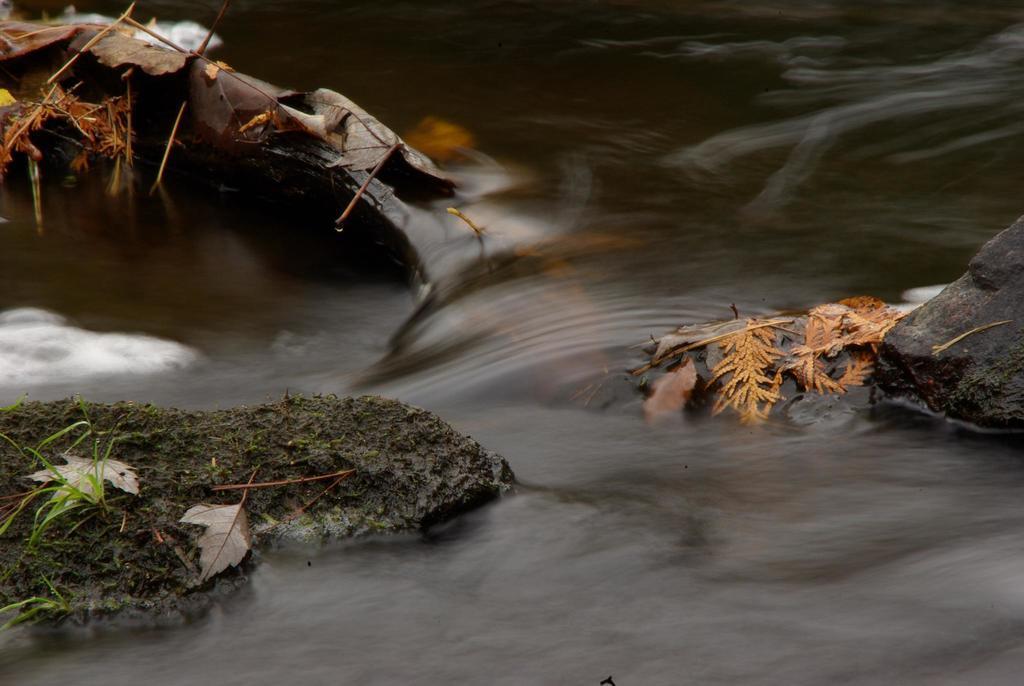In one or two sentences, can you explain what this image depicts? In this image we can see water is flowing in between the rocks. And leaves, grass and stems are present on the rocks. 